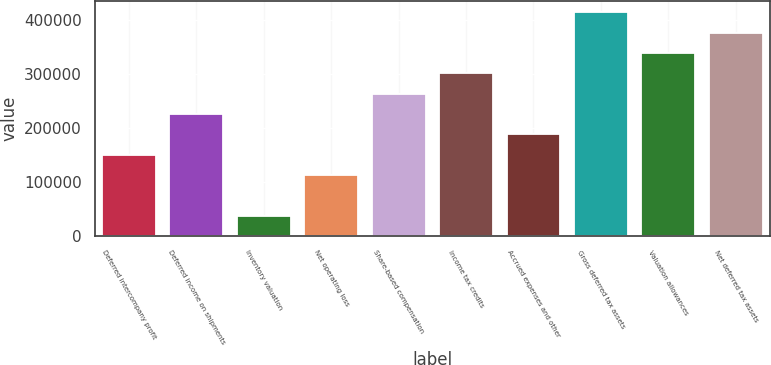Convert chart to OTSL. <chart><loc_0><loc_0><loc_500><loc_500><bar_chart><fcel>Deferred intercompany profit<fcel>Deferred income on shipments<fcel>Inventory valuation<fcel>Net operating loss<fcel>Share-based compensation<fcel>Income tax credits<fcel>Accrued expenses and other<fcel>Gross deferred tax assets<fcel>Valuation allowances<fcel>Net deferred tax assets<nl><fcel>151045<fcel>226268<fcel>38211.3<fcel>113434<fcel>263879<fcel>301490<fcel>188656<fcel>414324<fcel>339102<fcel>376713<nl></chart> 